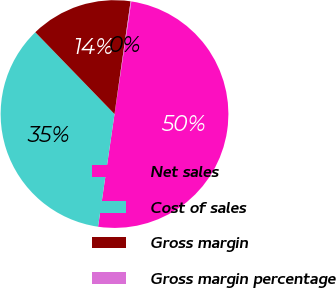Convert chart to OTSL. <chart><loc_0><loc_0><loc_500><loc_500><pie_chart><fcel>Net sales<fcel>Cost of sales<fcel>Gross margin<fcel>Gross margin percentage<nl><fcel>49.95%<fcel>35.45%<fcel>14.5%<fcel>0.1%<nl></chart> 